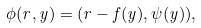<formula> <loc_0><loc_0><loc_500><loc_500>\phi ( r , y ) = ( r - f ( y ) , \psi ( y ) ) ,</formula> 